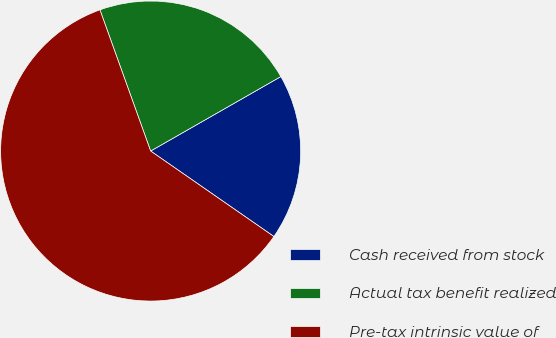Convert chart to OTSL. <chart><loc_0><loc_0><loc_500><loc_500><pie_chart><fcel>Cash received from stock<fcel>Actual tax benefit realized<fcel>Pre-tax intrinsic value of<nl><fcel>17.92%<fcel>22.22%<fcel>59.86%<nl></chart> 